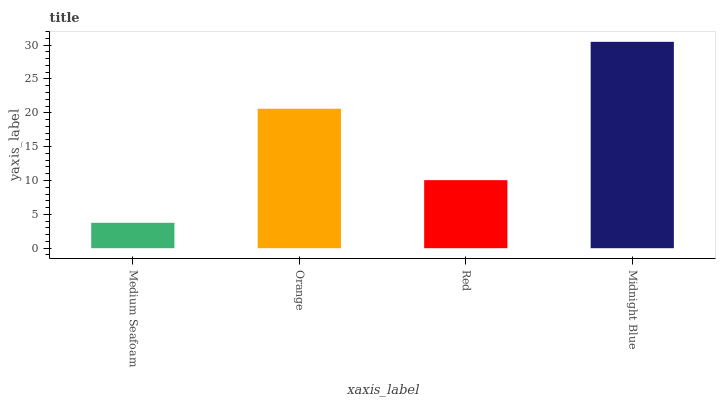Is Orange the minimum?
Answer yes or no. No. Is Orange the maximum?
Answer yes or no. No. Is Orange greater than Medium Seafoam?
Answer yes or no. Yes. Is Medium Seafoam less than Orange?
Answer yes or no. Yes. Is Medium Seafoam greater than Orange?
Answer yes or no. No. Is Orange less than Medium Seafoam?
Answer yes or no. No. Is Orange the high median?
Answer yes or no. Yes. Is Red the low median?
Answer yes or no. Yes. Is Red the high median?
Answer yes or no. No. Is Medium Seafoam the low median?
Answer yes or no. No. 